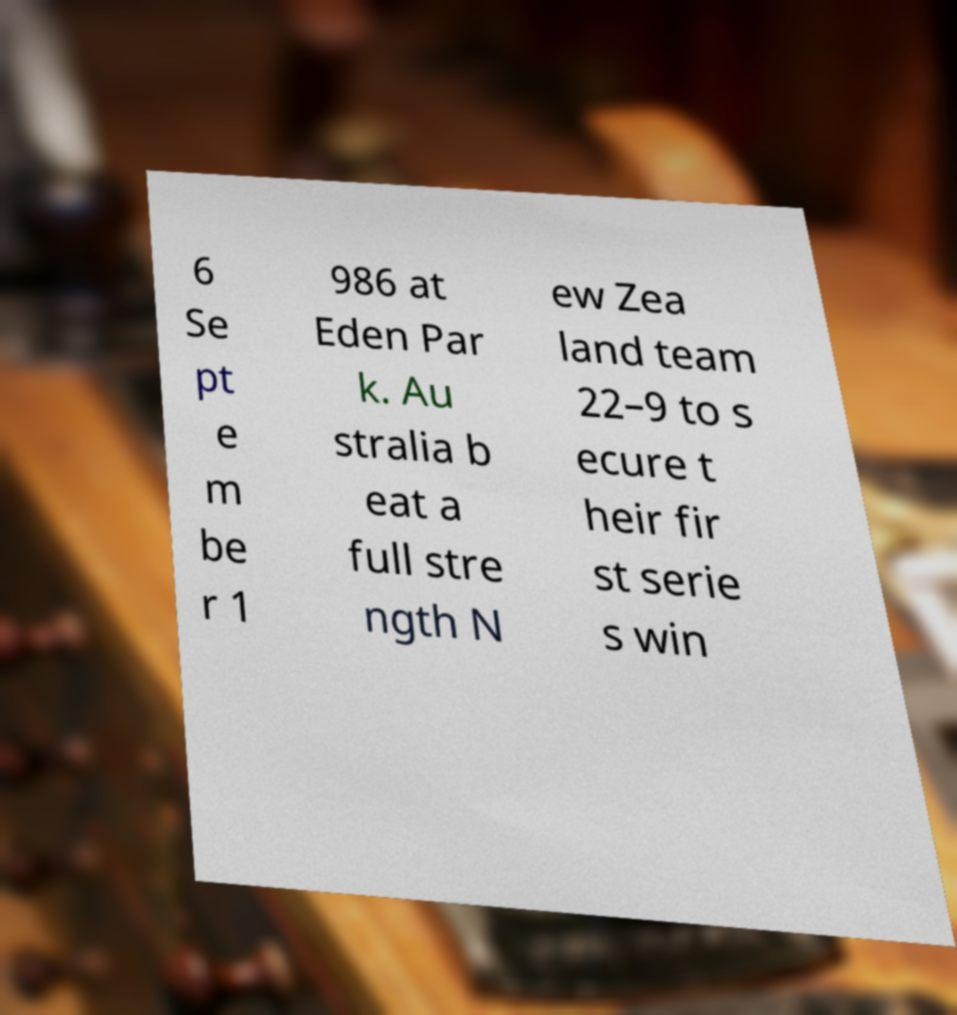Can you accurately transcribe the text from the provided image for me? 6 Se pt e m be r 1 986 at Eden Par k. Au stralia b eat a full stre ngth N ew Zea land team 22–9 to s ecure t heir fir st serie s win 